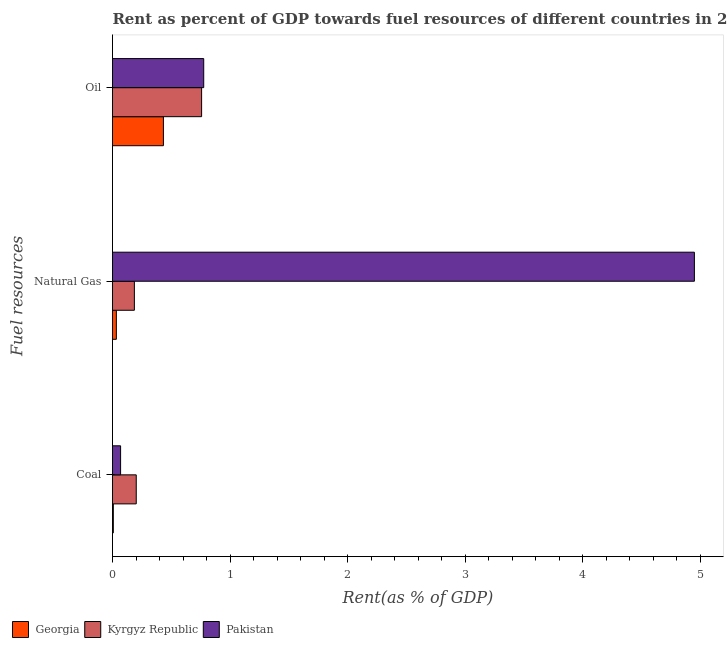Are the number of bars on each tick of the Y-axis equal?
Provide a succinct answer. Yes. What is the label of the 2nd group of bars from the top?
Your response must be concise. Natural Gas. What is the rent towards coal in Kyrgyz Republic?
Offer a very short reply. 0.2. Across all countries, what is the maximum rent towards coal?
Ensure brevity in your answer.  0.2. Across all countries, what is the minimum rent towards coal?
Offer a very short reply. 0.01. In which country was the rent towards oil minimum?
Provide a succinct answer. Georgia. What is the total rent towards oil in the graph?
Make the answer very short. 1.97. What is the difference between the rent towards oil in Pakistan and that in Kyrgyz Republic?
Your answer should be compact. 0.02. What is the difference between the rent towards natural gas in Georgia and the rent towards coal in Kyrgyz Republic?
Ensure brevity in your answer.  -0.17. What is the average rent towards oil per country?
Offer a terse response. 0.66. What is the difference between the rent towards coal and rent towards natural gas in Pakistan?
Your answer should be compact. -4.88. What is the ratio of the rent towards natural gas in Georgia to that in Kyrgyz Republic?
Your response must be concise. 0.18. Is the rent towards coal in Pakistan less than that in Kyrgyz Republic?
Offer a very short reply. Yes. What is the difference between the highest and the second highest rent towards oil?
Give a very brief answer. 0.02. What is the difference between the highest and the lowest rent towards coal?
Offer a terse response. 0.2. Are the values on the major ticks of X-axis written in scientific E-notation?
Keep it short and to the point. No. How many legend labels are there?
Provide a succinct answer. 3. What is the title of the graph?
Your answer should be very brief. Rent as percent of GDP towards fuel resources of different countries in 2004. What is the label or title of the X-axis?
Provide a succinct answer. Rent(as % of GDP). What is the label or title of the Y-axis?
Ensure brevity in your answer.  Fuel resources. What is the Rent(as % of GDP) in Georgia in Coal?
Ensure brevity in your answer.  0.01. What is the Rent(as % of GDP) of Kyrgyz Republic in Coal?
Give a very brief answer. 0.2. What is the Rent(as % of GDP) of Pakistan in Coal?
Give a very brief answer. 0.07. What is the Rent(as % of GDP) in Georgia in Natural Gas?
Ensure brevity in your answer.  0.03. What is the Rent(as % of GDP) of Kyrgyz Republic in Natural Gas?
Make the answer very short. 0.19. What is the Rent(as % of GDP) in Pakistan in Natural Gas?
Provide a short and direct response. 4.95. What is the Rent(as % of GDP) of Georgia in Oil?
Offer a very short reply. 0.43. What is the Rent(as % of GDP) in Kyrgyz Republic in Oil?
Your answer should be very brief. 0.76. What is the Rent(as % of GDP) of Pakistan in Oil?
Provide a succinct answer. 0.78. Across all Fuel resources, what is the maximum Rent(as % of GDP) in Georgia?
Ensure brevity in your answer.  0.43. Across all Fuel resources, what is the maximum Rent(as % of GDP) of Kyrgyz Republic?
Make the answer very short. 0.76. Across all Fuel resources, what is the maximum Rent(as % of GDP) of Pakistan?
Keep it short and to the point. 4.95. Across all Fuel resources, what is the minimum Rent(as % of GDP) in Georgia?
Ensure brevity in your answer.  0.01. Across all Fuel resources, what is the minimum Rent(as % of GDP) in Kyrgyz Republic?
Provide a short and direct response. 0.19. Across all Fuel resources, what is the minimum Rent(as % of GDP) in Pakistan?
Your answer should be compact. 0.07. What is the total Rent(as % of GDP) of Georgia in the graph?
Make the answer very short. 0.47. What is the total Rent(as % of GDP) of Kyrgyz Republic in the graph?
Make the answer very short. 1.15. What is the total Rent(as % of GDP) of Pakistan in the graph?
Keep it short and to the point. 5.8. What is the difference between the Rent(as % of GDP) of Georgia in Coal and that in Natural Gas?
Offer a terse response. -0.03. What is the difference between the Rent(as % of GDP) of Kyrgyz Republic in Coal and that in Natural Gas?
Provide a short and direct response. 0.02. What is the difference between the Rent(as % of GDP) of Pakistan in Coal and that in Natural Gas?
Ensure brevity in your answer.  -4.88. What is the difference between the Rent(as % of GDP) in Georgia in Coal and that in Oil?
Keep it short and to the point. -0.43. What is the difference between the Rent(as % of GDP) in Kyrgyz Republic in Coal and that in Oil?
Keep it short and to the point. -0.56. What is the difference between the Rent(as % of GDP) in Pakistan in Coal and that in Oil?
Provide a succinct answer. -0.71. What is the difference between the Rent(as % of GDP) of Georgia in Natural Gas and that in Oil?
Keep it short and to the point. -0.4. What is the difference between the Rent(as % of GDP) of Kyrgyz Republic in Natural Gas and that in Oil?
Keep it short and to the point. -0.57. What is the difference between the Rent(as % of GDP) in Pakistan in Natural Gas and that in Oil?
Provide a succinct answer. 4.17. What is the difference between the Rent(as % of GDP) of Georgia in Coal and the Rent(as % of GDP) of Kyrgyz Republic in Natural Gas?
Offer a terse response. -0.18. What is the difference between the Rent(as % of GDP) of Georgia in Coal and the Rent(as % of GDP) of Pakistan in Natural Gas?
Ensure brevity in your answer.  -4.94. What is the difference between the Rent(as % of GDP) of Kyrgyz Republic in Coal and the Rent(as % of GDP) of Pakistan in Natural Gas?
Keep it short and to the point. -4.75. What is the difference between the Rent(as % of GDP) of Georgia in Coal and the Rent(as % of GDP) of Kyrgyz Republic in Oil?
Make the answer very short. -0.75. What is the difference between the Rent(as % of GDP) of Georgia in Coal and the Rent(as % of GDP) of Pakistan in Oil?
Offer a terse response. -0.77. What is the difference between the Rent(as % of GDP) of Kyrgyz Republic in Coal and the Rent(as % of GDP) of Pakistan in Oil?
Give a very brief answer. -0.57. What is the difference between the Rent(as % of GDP) of Georgia in Natural Gas and the Rent(as % of GDP) of Kyrgyz Republic in Oil?
Provide a succinct answer. -0.73. What is the difference between the Rent(as % of GDP) in Georgia in Natural Gas and the Rent(as % of GDP) in Pakistan in Oil?
Provide a short and direct response. -0.74. What is the difference between the Rent(as % of GDP) in Kyrgyz Republic in Natural Gas and the Rent(as % of GDP) in Pakistan in Oil?
Your answer should be compact. -0.59. What is the average Rent(as % of GDP) of Georgia per Fuel resources?
Keep it short and to the point. 0.16. What is the average Rent(as % of GDP) in Kyrgyz Republic per Fuel resources?
Your response must be concise. 0.38. What is the average Rent(as % of GDP) in Pakistan per Fuel resources?
Your response must be concise. 1.93. What is the difference between the Rent(as % of GDP) of Georgia and Rent(as % of GDP) of Kyrgyz Republic in Coal?
Give a very brief answer. -0.2. What is the difference between the Rent(as % of GDP) of Georgia and Rent(as % of GDP) of Pakistan in Coal?
Ensure brevity in your answer.  -0.06. What is the difference between the Rent(as % of GDP) in Kyrgyz Republic and Rent(as % of GDP) in Pakistan in Coal?
Provide a succinct answer. 0.13. What is the difference between the Rent(as % of GDP) of Georgia and Rent(as % of GDP) of Kyrgyz Republic in Natural Gas?
Offer a terse response. -0.15. What is the difference between the Rent(as % of GDP) of Georgia and Rent(as % of GDP) of Pakistan in Natural Gas?
Give a very brief answer. -4.92. What is the difference between the Rent(as % of GDP) in Kyrgyz Republic and Rent(as % of GDP) in Pakistan in Natural Gas?
Provide a short and direct response. -4.76. What is the difference between the Rent(as % of GDP) in Georgia and Rent(as % of GDP) in Kyrgyz Republic in Oil?
Provide a succinct answer. -0.32. What is the difference between the Rent(as % of GDP) in Georgia and Rent(as % of GDP) in Pakistan in Oil?
Keep it short and to the point. -0.34. What is the difference between the Rent(as % of GDP) of Kyrgyz Republic and Rent(as % of GDP) of Pakistan in Oil?
Provide a short and direct response. -0.02. What is the ratio of the Rent(as % of GDP) of Georgia in Coal to that in Natural Gas?
Offer a terse response. 0.21. What is the ratio of the Rent(as % of GDP) of Kyrgyz Republic in Coal to that in Natural Gas?
Make the answer very short. 1.09. What is the ratio of the Rent(as % of GDP) of Pakistan in Coal to that in Natural Gas?
Your answer should be compact. 0.01. What is the ratio of the Rent(as % of GDP) in Georgia in Coal to that in Oil?
Your answer should be compact. 0.02. What is the ratio of the Rent(as % of GDP) of Kyrgyz Republic in Coal to that in Oil?
Your answer should be very brief. 0.27. What is the ratio of the Rent(as % of GDP) of Pakistan in Coal to that in Oil?
Ensure brevity in your answer.  0.09. What is the ratio of the Rent(as % of GDP) of Georgia in Natural Gas to that in Oil?
Provide a short and direct response. 0.08. What is the ratio of the Rent(as % of GDP) of Kyrgyz Republic in Natural Gas to that in Oil?
Give a very brief answer. 0.25. What is the ratio of the Rent(as % of GDP) of Pakistan in Natural Gas to that in Oil?
Offer a terse response. 6.38. What is the difference between the highest and the second highest Rent(as % of GDP) of Georgia?
Offer a terse response. 0.4. What is the difference between the highest and the second highest Rent(as % of GDP) in Kyrgyz Republic?
Give a very brief answer. 0.56. What is the difference between the highest and the second highest Rent(as % of GDP) of Pakistan?
Your answer should be very brief. 4.17. What is the difference between the highest and the lowest Rent(as % of GDP) in Georgia?
Keep it short and to the point. 0.43. What is the difference between the highest and the lowest Rent(as % of GDP) of Kyrgyz Republic?
Give a very brief answer. 0.57. What is the difference between the highest and the lowest Rent(as % of GDP) of Pakistan?
Your answer should be compact. 4.88. 